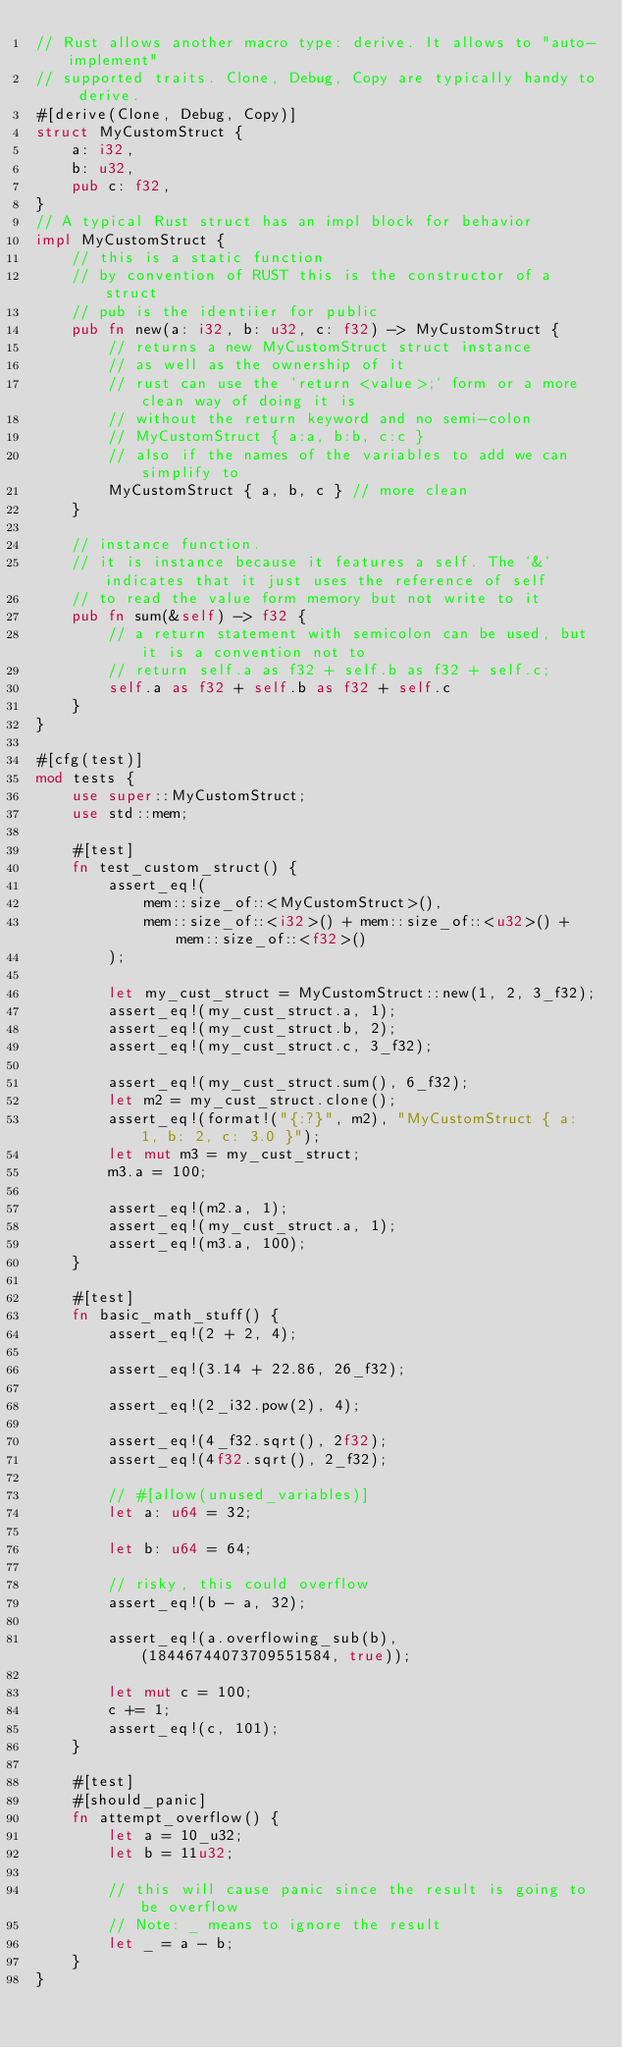Convert code to text. <code><loc_0><loc_0><loc_500><loc_500><_Rust_>// Rust allows another macro type: derive. It allows to "auto-implement"
// supported traits. Clone, Debug, Copy are typically handy to derive.
#[derive(Clone, Debug, Copy)]
struct MyCustomStruct {
    a: i32,
    b: u32,
    pub c: f32,
}
// A typical Rust struct has an impl block for behavior
impl MyCustomStruct {
    // this is a static function
    // by convention of RUST this is the constructor of a struct
    // pub is the identiier for public
    pub fn new(a: i32, b: u32, c: f32) -> MyCustomStruct {
        // returns a new MyCustomStruct struct instance
        // as well as the ownership of it
        // rust can use the `return <value>;` form or a more clean way of doing it is
        // without the return keyword and no semi-colon
        // MyCustomStruct { a:a, b:b, c:c }
        // also if the names of the variables to add we can simplify to
        MyCustomStruct { a, b, c } // more clean
    }

    // instance function.
    // it is instance because it features a self. The `&` indicates that it just uses the reference of self
    // to read the value form memory but not write to it
    pub fn sum(&self) -> f32 {
        // a return statement with semicolon can be used, but it is a convention not to
        // return self.a as f32 + self.b as f32 + self.c;
        self.a as f32 + self.b as f32 + self.c
    }
}

#[cfg(test)]
mod tests {
    use super::MyCustomStruct;
    use std::mem;

    #[test]
    fn test_custom_struct() {
        assert_eq!(
            mem::size_of::<MyCustomStruct>(),
            mem::size_of::<i32>() + mem::size_of::<u32>() + mem::size_of::<f32>()
        );

        let my_cust_struct = MyCustomStruct::new(1, 2, 3_f32);
        assert_eq!(my_cust_struct.a, 1);
        assert_eq!(my_cust_struct.b, 2);
        assert_eq!(my_cust_struct.c, 3_f32);

        assert_eq!(my_cust_struct.sum(), 6_f32);
        let m2 = my_cust_struct.clone();
        assert_eq!(format!("{:?}", m2), "MyCustomStruct { a: 1, b: 2, c: 3.0 }");
        let mut m3 = my_cust_struct;
        m3.a = 100;

        assert_eq!(m2.a, 1);
        assert_eq!(my_cust_struct.a, 1);
        assert_eq!(m3.a, 100);
    }

    #[test]
    fn basic_math_stuff() {
        assert_eq!(2 + 2, 4);

        assert_eq!(3.14 + 22.86, 26_f32);

        assert_eq!(2_i32.pow(2), 4);

        assert_eq!(4_f32.sqrt(), 2f32);
        assert_eq!(4f32.sqrt(), 2_f32);

        // #[allow(unused_variables)]
        let a: u64 = 32;

        let b: u64 = 64;

        // risky, this could overflow
        assert_eq!(b - a, 32);

        assert_eq!(a.overflowing_sub(b), (18446744073709551584, true));

        let mut c = 100;
        c += 1;
        assert_eq!(c, 101);
    }

    #[test]
    #[should_panic]
    fn attempt_overflow() {
        let a = 10_u32;
        let b = 11u32;

        // this will cause panic since the result is going to be overflow
        // Note: _ means to ignore the result
        let _ = a - b;
    }
}
</code> 